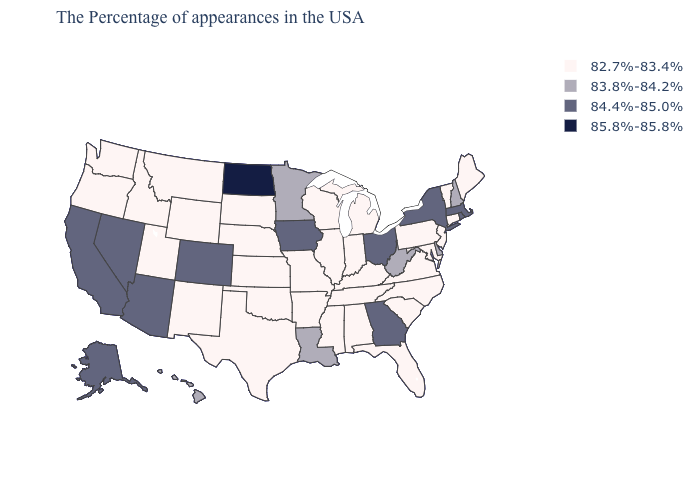Does Wyoming have the lowest value in the USA?
Write a very short answer. Yes. What is the value of North Dakota?
Quick response, please. 85.8%-85.8%. Does the map have missing data?
Answer briefly. No. What is the value of Tennessee?
Keep it brief. 82.7%-83.4%. Does Georgia have a higher value than Ohio?
Be succinct. No. Name the states that have a value in the range 85.8%-85.8%?
Quick response, please. North Dakota. Which states hav the highest value in the MidWest?
Keep it brief. North Dakota. Name the states that have a value in the range 83.8%-84.2%?
Be succinct. New Hampshire, Delaware, West Virginia, Louisiana, Minnesota, Hawaii. What is the lowest value in the USA?
Keep it brief. 82.7%-83.4%. Does the first symbol in the legend represent the smallest category?
Concise answer only. Yes. What is the value of Iowa?
Short answer required. 84.4%-85.0%. Name the states that have a value in the range 85.8%-85.8%?
Write a very short answer. North Dakota. Name the states that have a value in the range 85.8%-85.8%?
Write a very short answer. North Dakota. Is the legend a continuous bar?
Write a very short answer. No. Name the states that have a value in the range 84.4%-85.0%?
Quick response, please. Massachusetts, Rhode Island, New York, Ohio, Georgia, Iowa, Colorado, Arizona, Nevada, California, Alaska. 